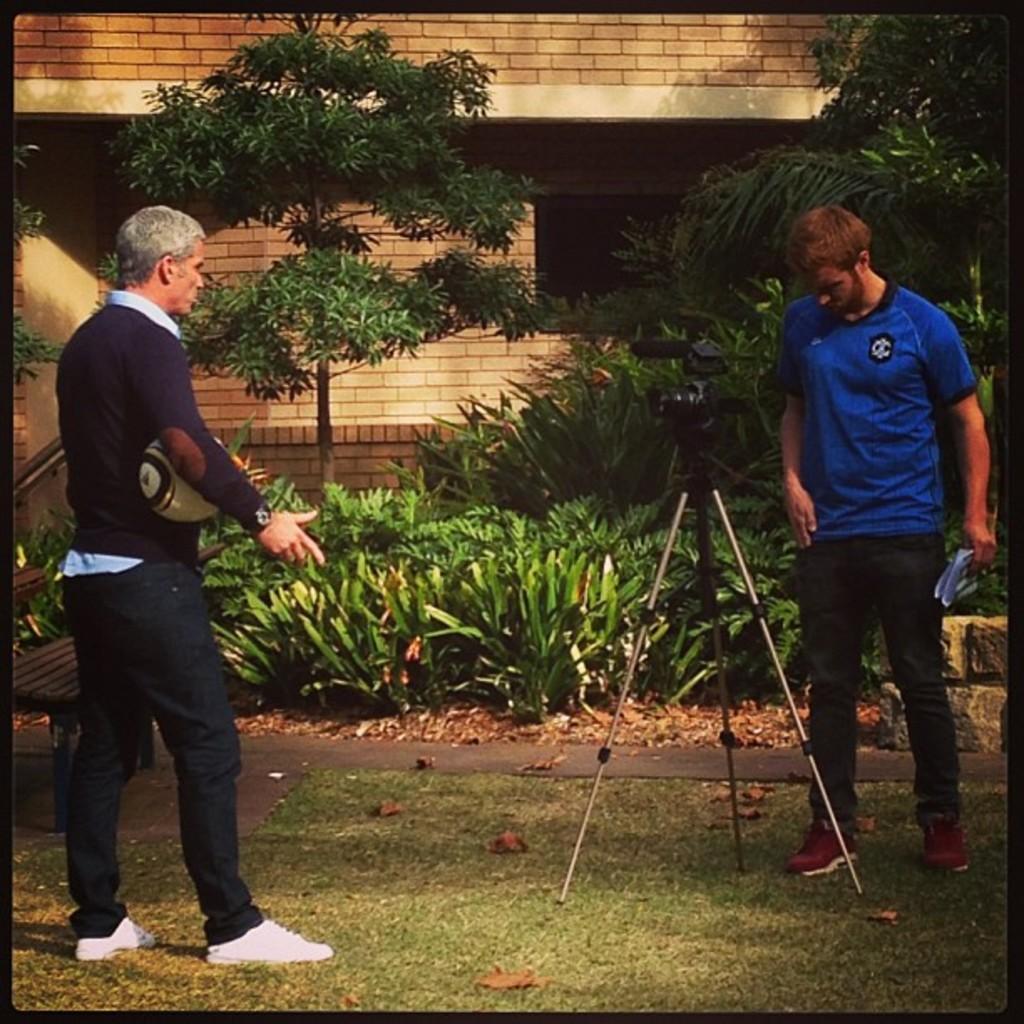Can you describe this image briefly? In this picture there is a person wearing white shoes is standing on a greenery ground and holding a ball under his arms and there is a camera attached to a stand in front of him and there is another person wearing blue T-shirt is standing in the right corner and there are few plants,trees and a building in the background. 